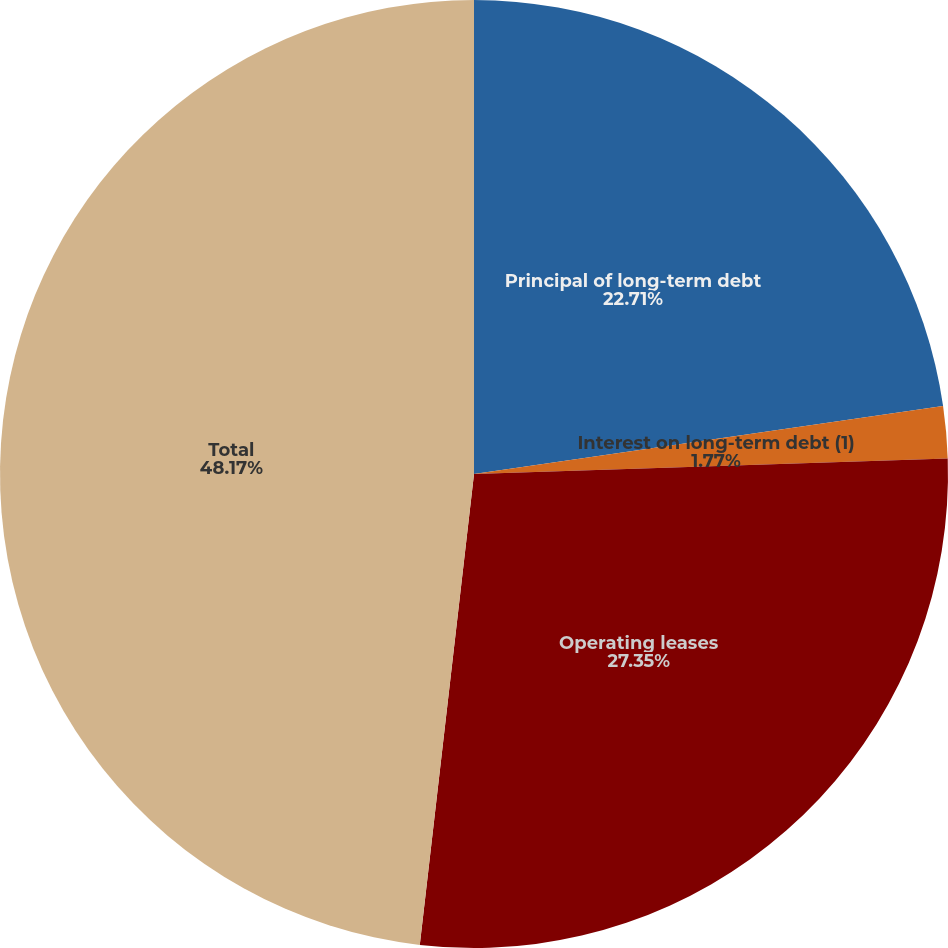Convert chart to OTSL. <chart><loc_0><loc_0><loc_500><loc_500><pie_chart><fcel>Principal of long-term debt<fcel>Interest on long-term debt (1)<fcel>Operating leases<fcel>Total<nl><fcel>22.71%<fcel>1.77%<fcel>27.35%<fcel>48.18%<nl></chart> 